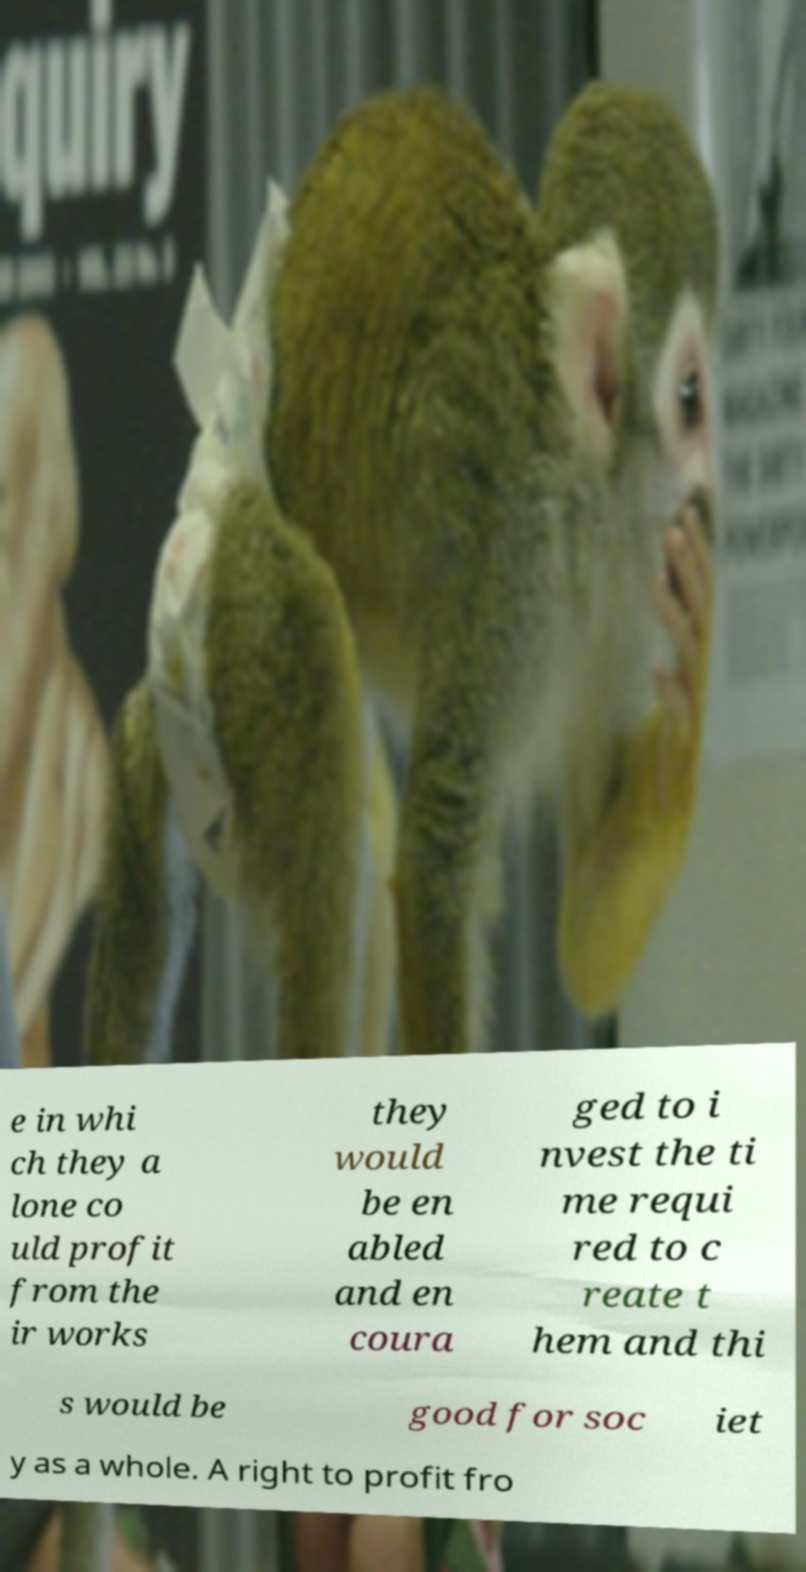Can you accurately transcribe the text from the provided image for me? e in whi ch they a lone co uld profit from the ir works they would be en abled and en coura ged to i nvest the ti me requi red to c reate t hem and thi s would be good for soc iet y as a whole. A right to profit fro 